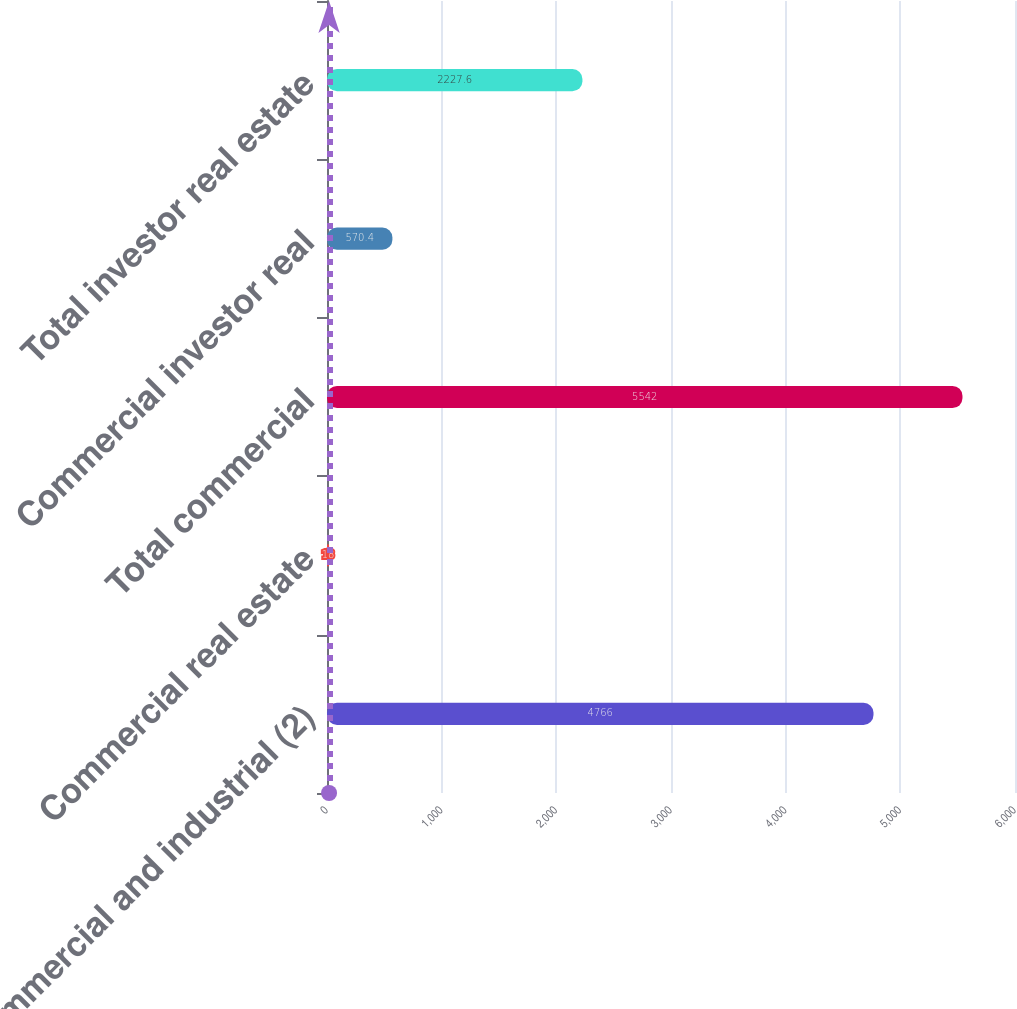Convert chart. <chart><loc_0><loc_0><loc_500><loc_500><bar_chart><fcel>Commercial and industrial (2)<fcel>Commercial real estate<fcel>Total commercial<fcel>Commercial investor real<fcel>Total investor real estate<nl><fcel>4766<fcel>18<fcel>5542<fcel>570.4<fcel>2227.6<nl></chart> 